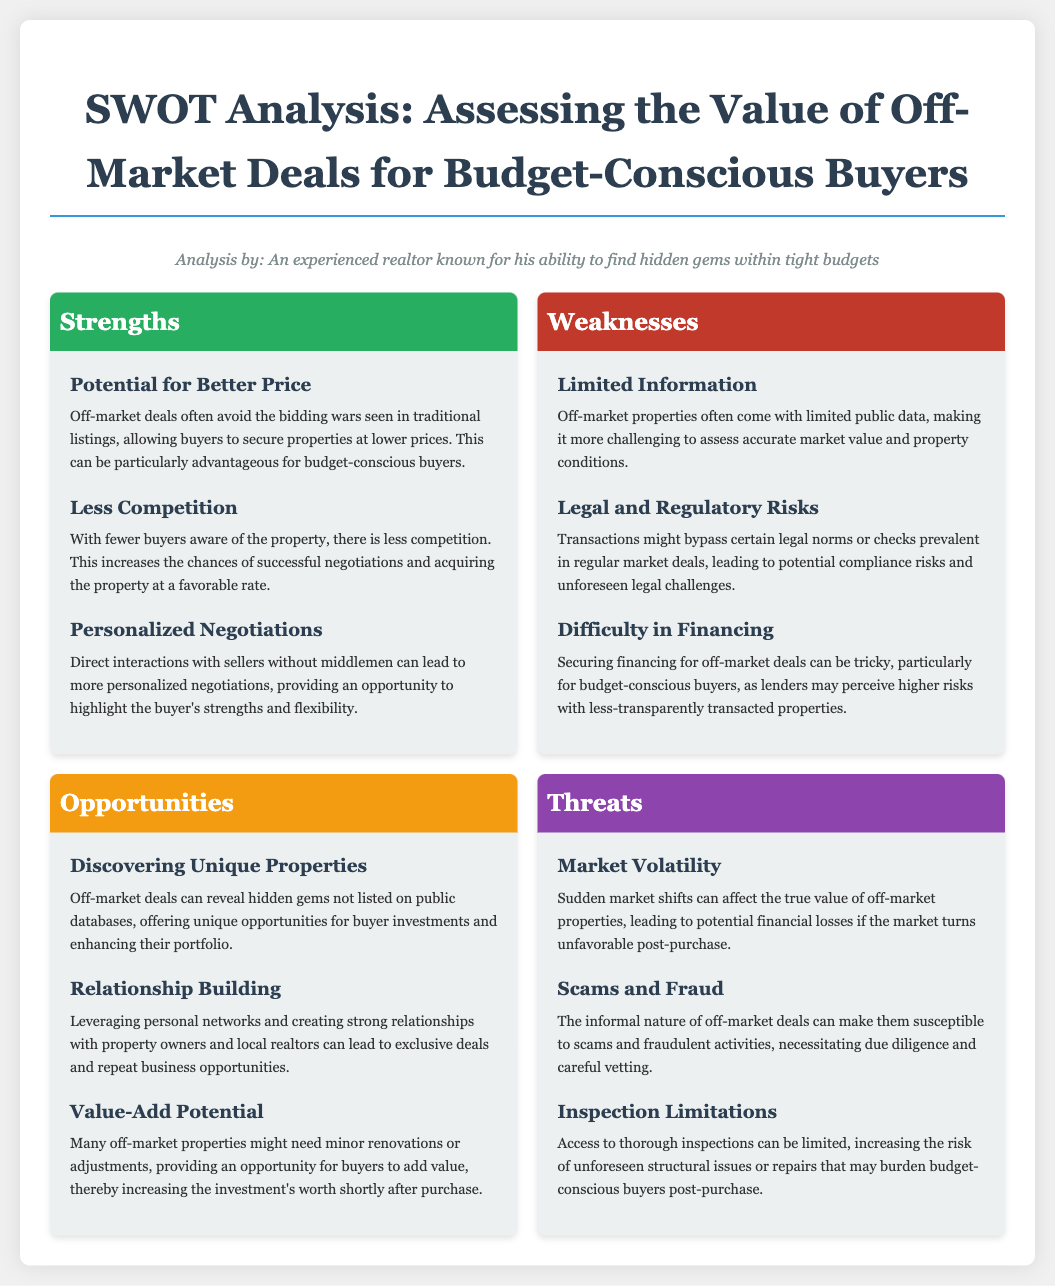What is one strength of off-market deals? A specific strength mentioned in the document is the potential for better price, which can help budget-conscious buyers.
Answer: Potential for better price What is a weakness associated with off-market properties? The document specifies limited information as a weakness, making it tough to assess market value accurately.
Answer: Limited Information What opportunity is highlighted in the analysis? Discovering unique properties is an opportunity mentioned, allowing buyers access to investments not listed publicly.
Answer: Discovering Unique Properties How many strengths are listed in the document? The document outlines three strengths related to off-market deals for buyers.
Answer: 3 What type of risk is associated with financing off-market deals? The document states that securing financing can pose difficulty, indicating a legal and regulatory risk.
Answer: Legal and Regulatory Risks What is a threat mentioned that relates to market conditions? Market volatility is a threat listed in the SWOT analysis that can impact property values.
Answer: Market Volatility What does "value-add potential" refer to in the document? Value-add potential refers to the ability to make minor renovations to increase the property's worth shortly after purchase.
Answer: Value-Add Potential Which section in the SWOT analysis discusses less competition? The strengths section discusses less competition, which helps negotiations and acquisition efforts.
Answer: Strengths What can be a consequence of the informal nature of off-market deals? The document mentions scams and fraud as a consequence linked to the informal nature of these deals.
Answer: Scams and Fraud 